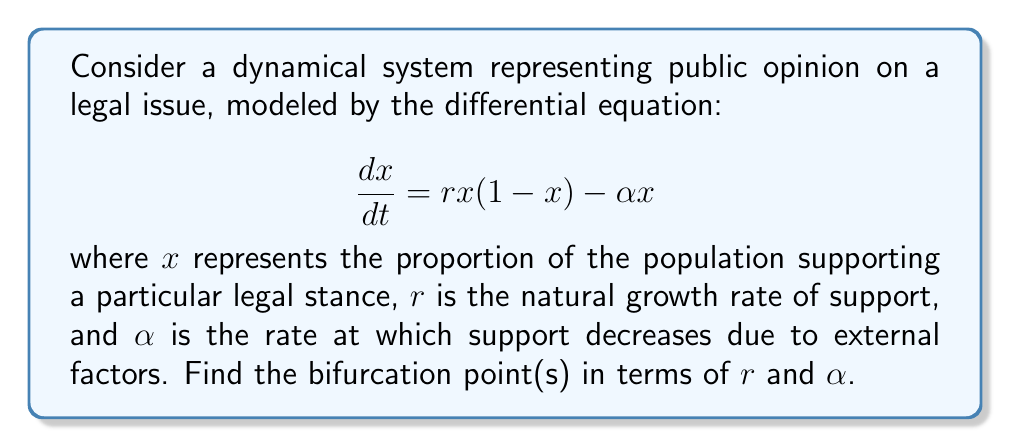Could you help me with this problem? To find the bifurcation points, we need to follow these steps:

1) First, find the equilibrium points by setting $\frac{dx}{dt} = 0$:

   $$rx(1-x) - \alpha x = 0$$
   $$x(r(1-x) - \alpha) = 0$$

2) This gives us two equilibrium points:
   $x_1 = 0$ and $x_2 = 1 - \frac{\alpha}{r}$

3) The second equilibrium point $x_2$ only exists when $1 - \frac{\alpha}{r} > 0$, or $r > \alpha$.

4) To determine stability, we find the derivative of $\frac{dx}{dt}$ with respect to $x$:

   $$\frac{d}{dx}(\frac{dx}{dt}) = r(1-2x) - \alpha$$

5) At $x_1 = 0$, the stability is determined by:
   $$r - \alpha$$
   $x_1$ is stable when $r - \alpha < 0$, or $r < \alpha$

6) At $x_2 = 1 - \frac{\alpha}{r}$, the stability is determined by:
   $$r(1-2(1-\frac{\alpha}{r})) - \alpha = \alpha - r$$
   $x_2$ is stable when $\alpha - r < 0$, or $r > \alpha$

7) The bifurcation occurs when the stability of $x_1$ changes, which happens when:
   $$r - \alpha = 0$$
   $$r = \alpha$$

This point represents a transcritical bifurcation, where $x_1$ and $x_2$ exchange stability.
Answer: $r = \alpha$ 